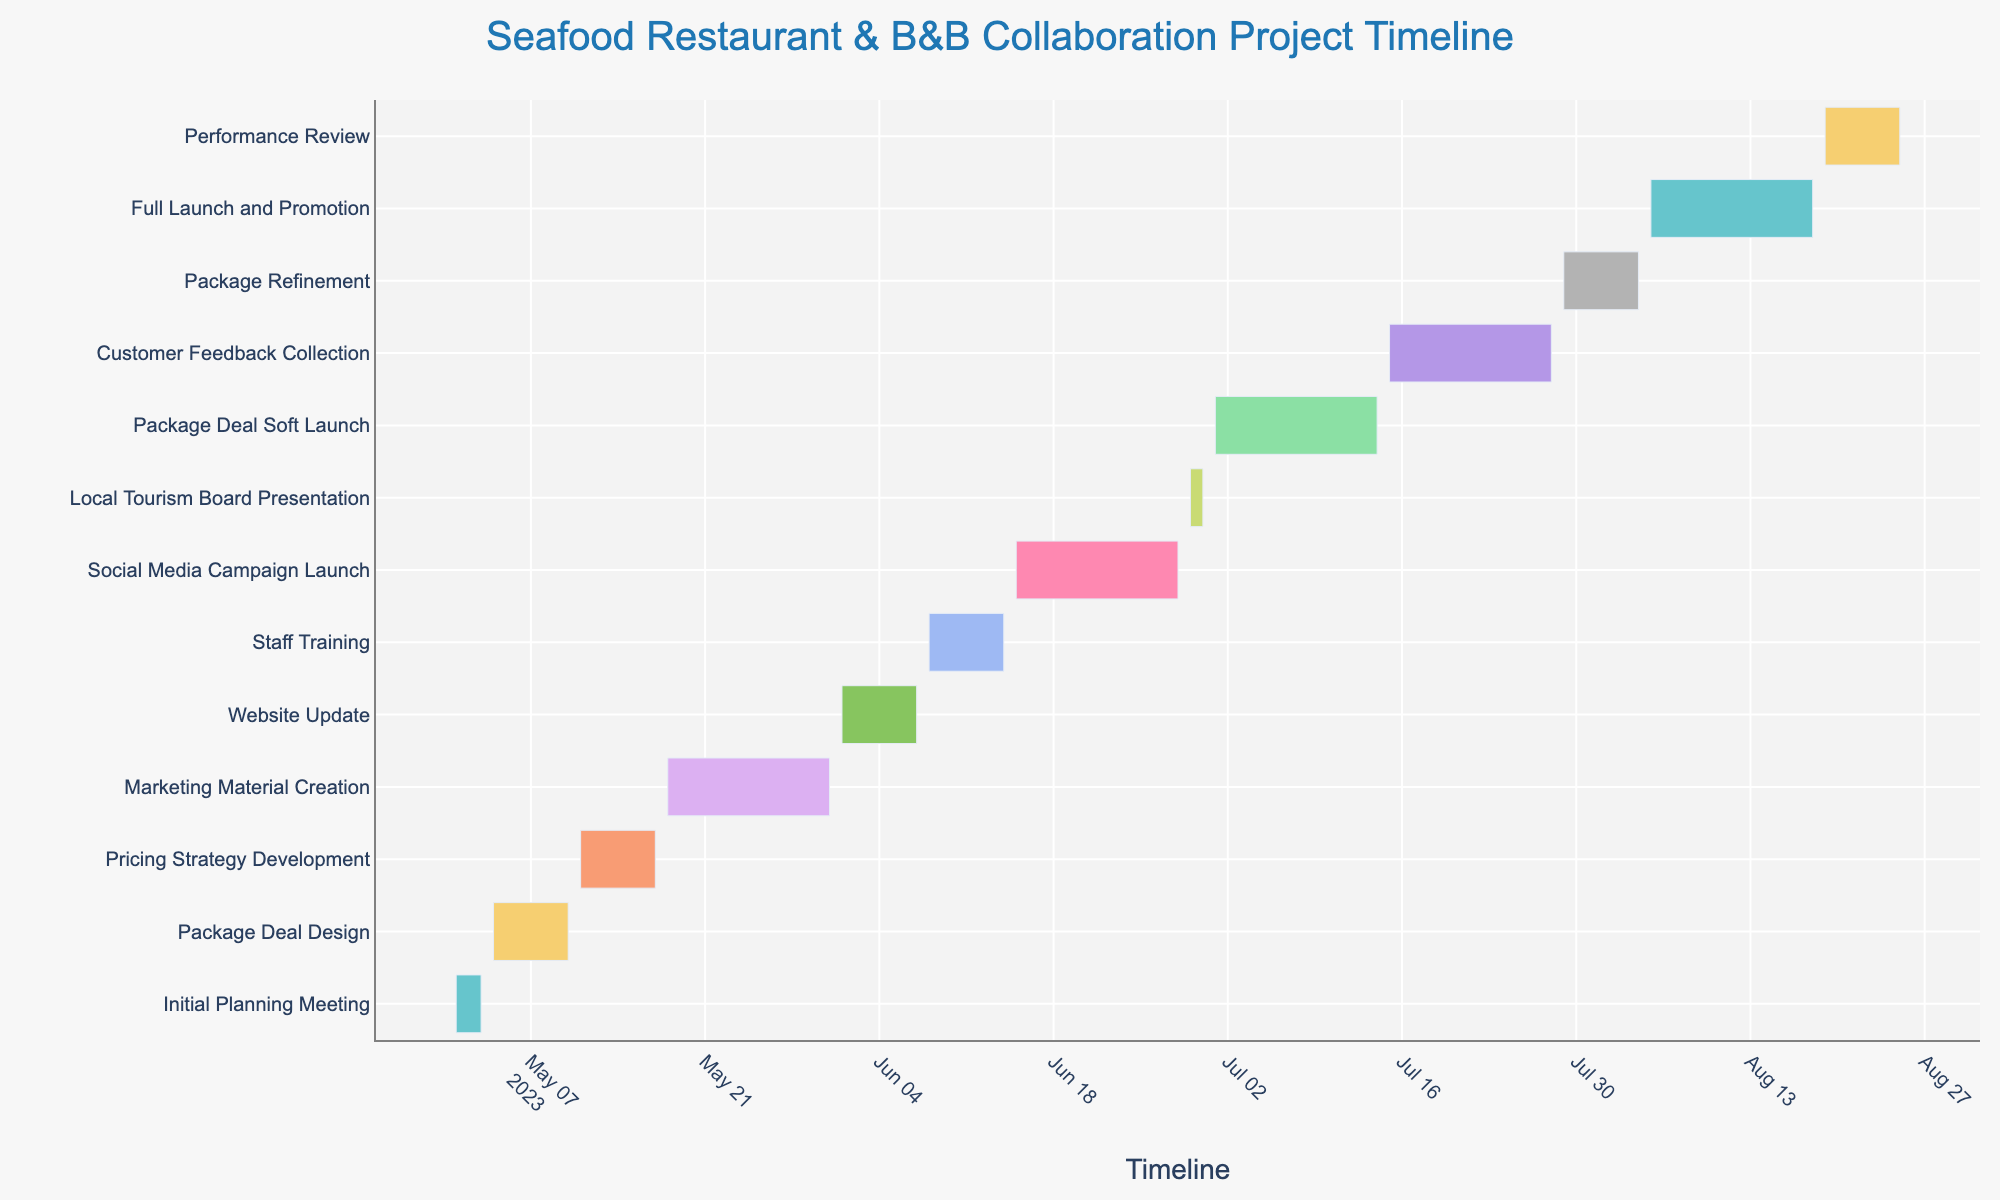What is the title of the Gantt chart? The title of a figure can typically be found at the top of the chart. In this case, the title appears centered at the top of the chart.
Answer: Seafood Restaurant & B&B Collaboration Project Timeline When does the "Marketing Material Creation" task start and end? To find the start and end dates of a specific task, look for the bar representing that task and refer to the dates indicated at the edges of the bar.
Answer: Starts on May 18, 2023, and ends on May 31, 2023 How long is the duration of the "Website Update" task? To find the duration of a specific task, locate the bar representing that task and look for the duration either labeled on the bar or calculated from the start to end dates.
Answer: 7 days Which task has the shortest duration? To identify the shortest duration task, compare the lengths of all bars or check the labeled durations next to each bar.
Answer: Local Tourism Board Presentation How many tasks have a duration longer than 10 days? To answer, count the number of tasks that have durations exceeding 10 days by looking at the duration information for each task.
Answer: 6 tasks Which task starts immediately after the "Staff Training" ends? To find the task that starts immediately after another, identify the end date of the first task and the start date of the subsequent task.
Answer: Social Media Campaign Launch Which two tasks overlap in their timelines? To find overlapping tasks, visually inspect the bars to see which ones span the same dates.
Answer: Social Media Campaign Launch and Website Update What is the difference in duration between "Package Deal Soft Launch" and "Package Refinement"? Find the durations of both tasks from the chart and subtract the shorter duration from the longer one.
Answer: 7 days How many tasks begin in June 2023? Look at the start dates of all tasks and count those beginning in June 2023.
Answer: 4 tasks What is the average duration of tasks in the project? Calculate the average by summing up all task durations and dividing by the number of tasks. The sum of durations is (3+7+7+14+7+7+14+2+14+14+7+14+7) = 111 days. There are 13 tasks, so 111/13 = 8.54 days.
Answer: 8.54 days 